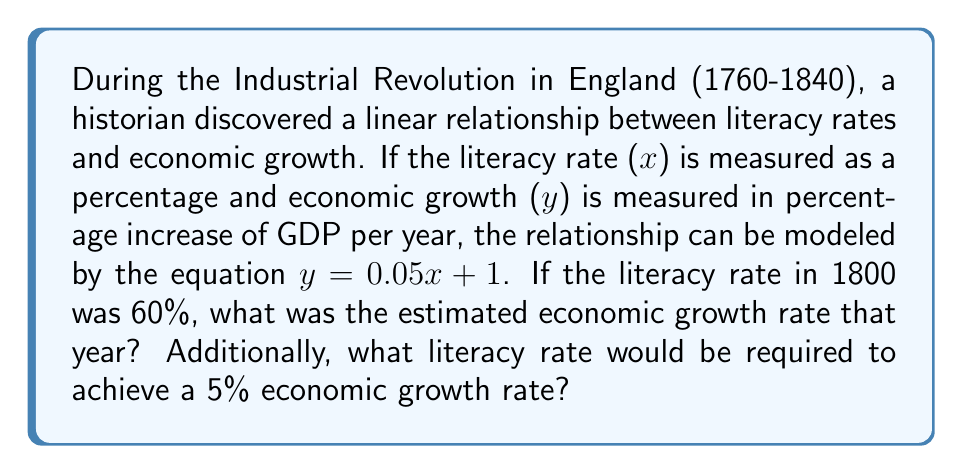Could you help me with this problem? 1. We are given the linear equation $y = 0.05x + 1$, where:
   $x$ = literacy rate (%)
   $y$ = economic growth rate (% increase in GDP per year)

2. To find the economic growth rate in 1800:
   - Literacy rate in 1800 was 60%
   - Substitute $x = 60$ into the equation:
     $y = 0.05(60) + 1$
     $y = 3 + 1 = 4$

3. To find the literacy rate required for 5% economic growth:
   - Set $y = 5$ and solve for $x$:
     $5 = 0.05x + 1$
     $4 = 0.05x$
     $x = 4 / 0.05 = 80$

[asy]
size(200,200);
import graph;

xaxis("Literacy Rate (%)",0,100,Arrows);
yaxis("Economic Growth Rate (%)",0,6,Arrows);

draw((0,1)--(100,6),blue);

dot((60,4),red);
dot((80,5),red);

label("(60, 4)",(60,4),SE);
label("(80, 5)",(80,5),NW);
[/asy]
Answer: 4% growth in 1800; 80% literacy for 5% growth 